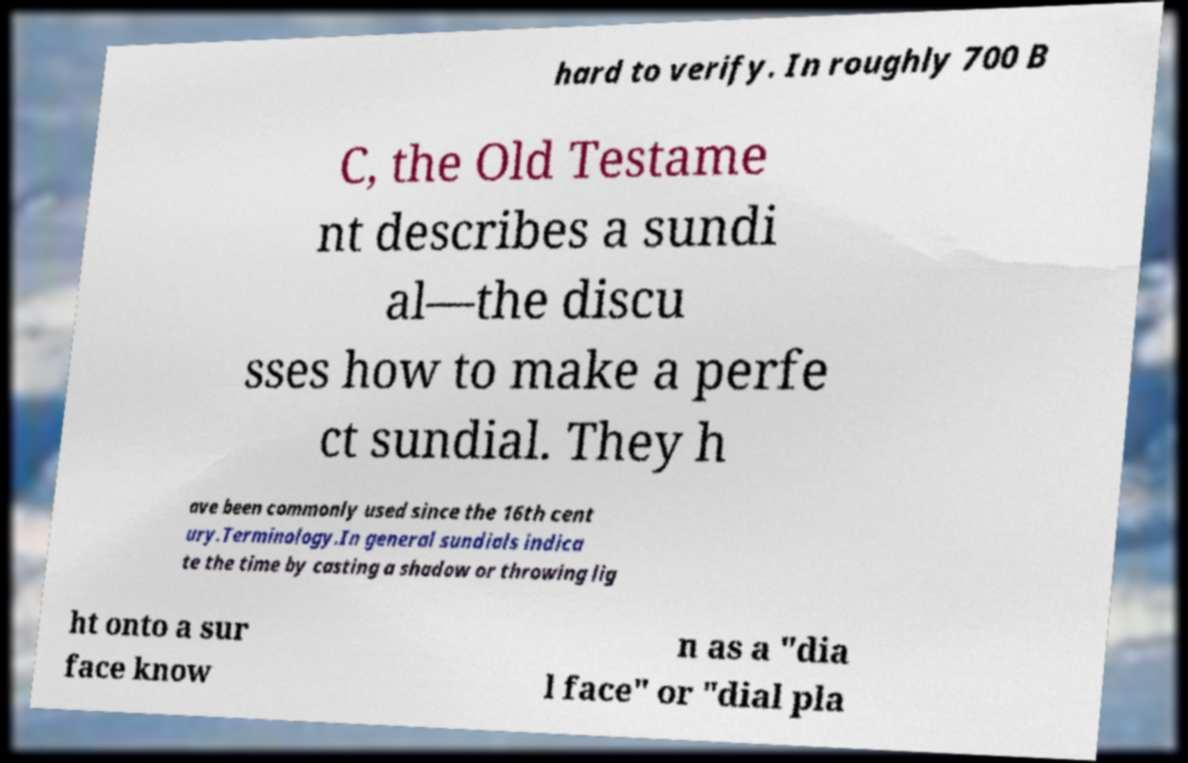What messages or text are displayed in this image? I need them in a readable, typed format. hard to verify. In roughly 700 B C, the Old Testame nt describes a sundi al—the discu sses how to make a perfe ct sundial. They h ave been commonly used since the 16th cent ury.Terminology.In general sundials indica te the time by casting a shadow or throwing lig ht onto a sur face know n as a "dia l face" or "dial pla 